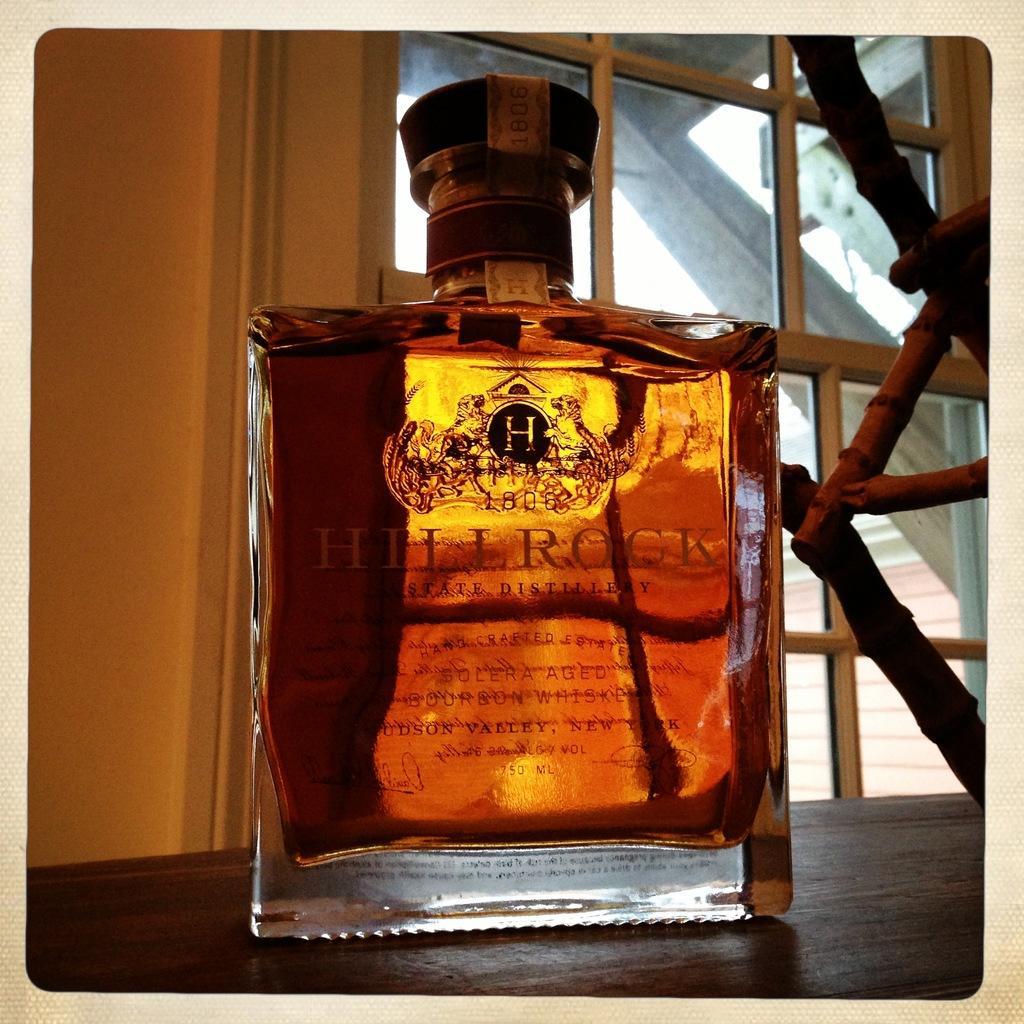Describe this image in one or two sentences. In this image we can see the wine bottle on the wooden surface. And we can see a window and the wall. 